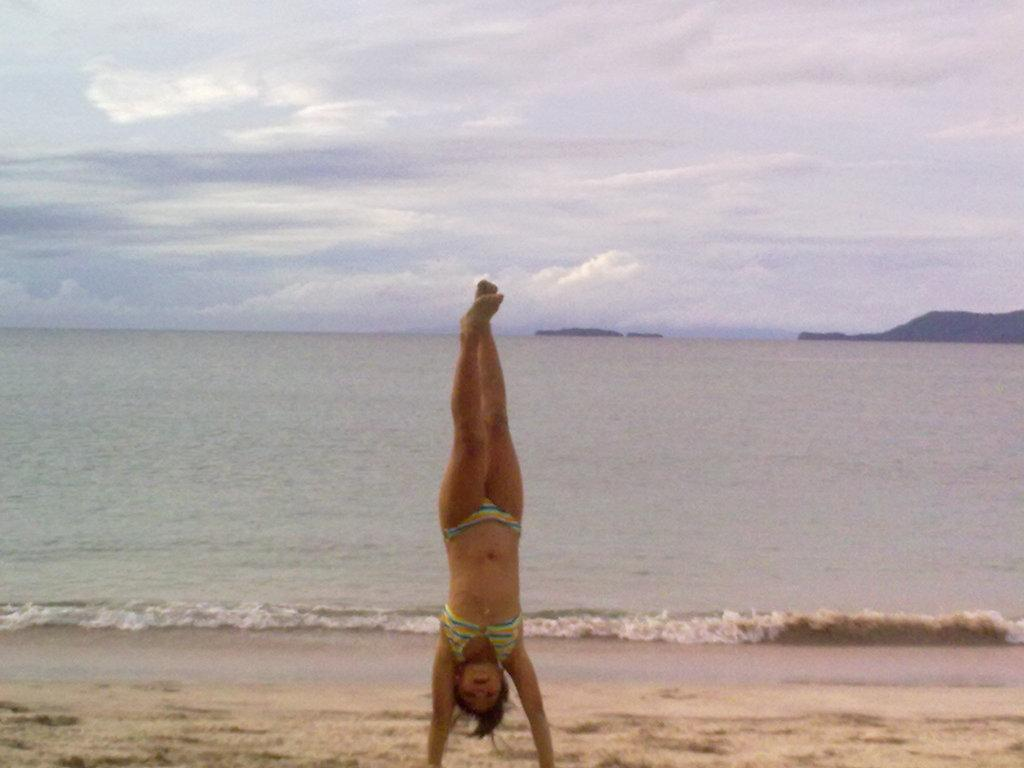Who or what is the main subject in the image? There is a person in the image. What can be seen in the background of the image? There is an ocean in the background of the image. What is present in the foreground of the image? There is sand in the foreground of the image. How many mountains are visible in the image? There are two mountains visible in the image. What is visible in the sky at the top of the image? Clouds are present in the sky at the top of the image. What type of cake is being served at the person's birthday party in the image? There is no cake or birthday party present in the image. What disease is the person in the image suffering from? There is no indication of any disease in the image; it only shows a person in a natural setting. 